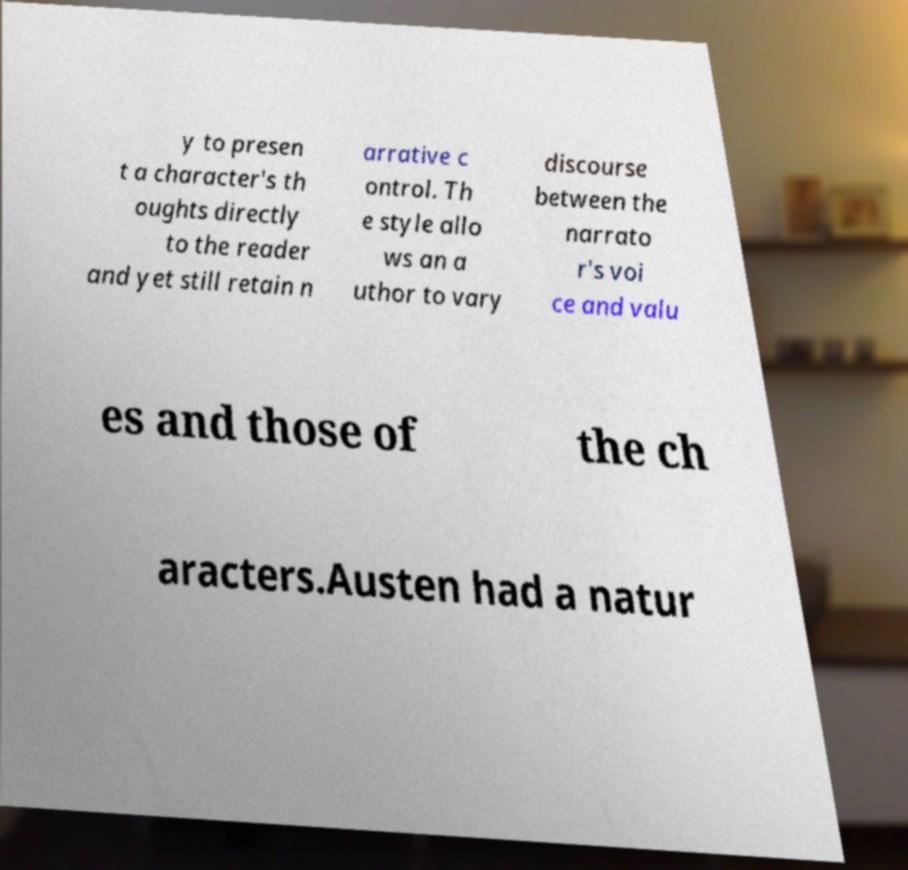I need the written content from this picture converted into text. Can you do that? y to presen t a character's th oughts directly to the reader and yet still retain n arrative c ontrol. Th e style allo ws an a uthor to vary discourse between the narrato r's voi ce and valu es and those of the ch aracters.Austen had a natur 